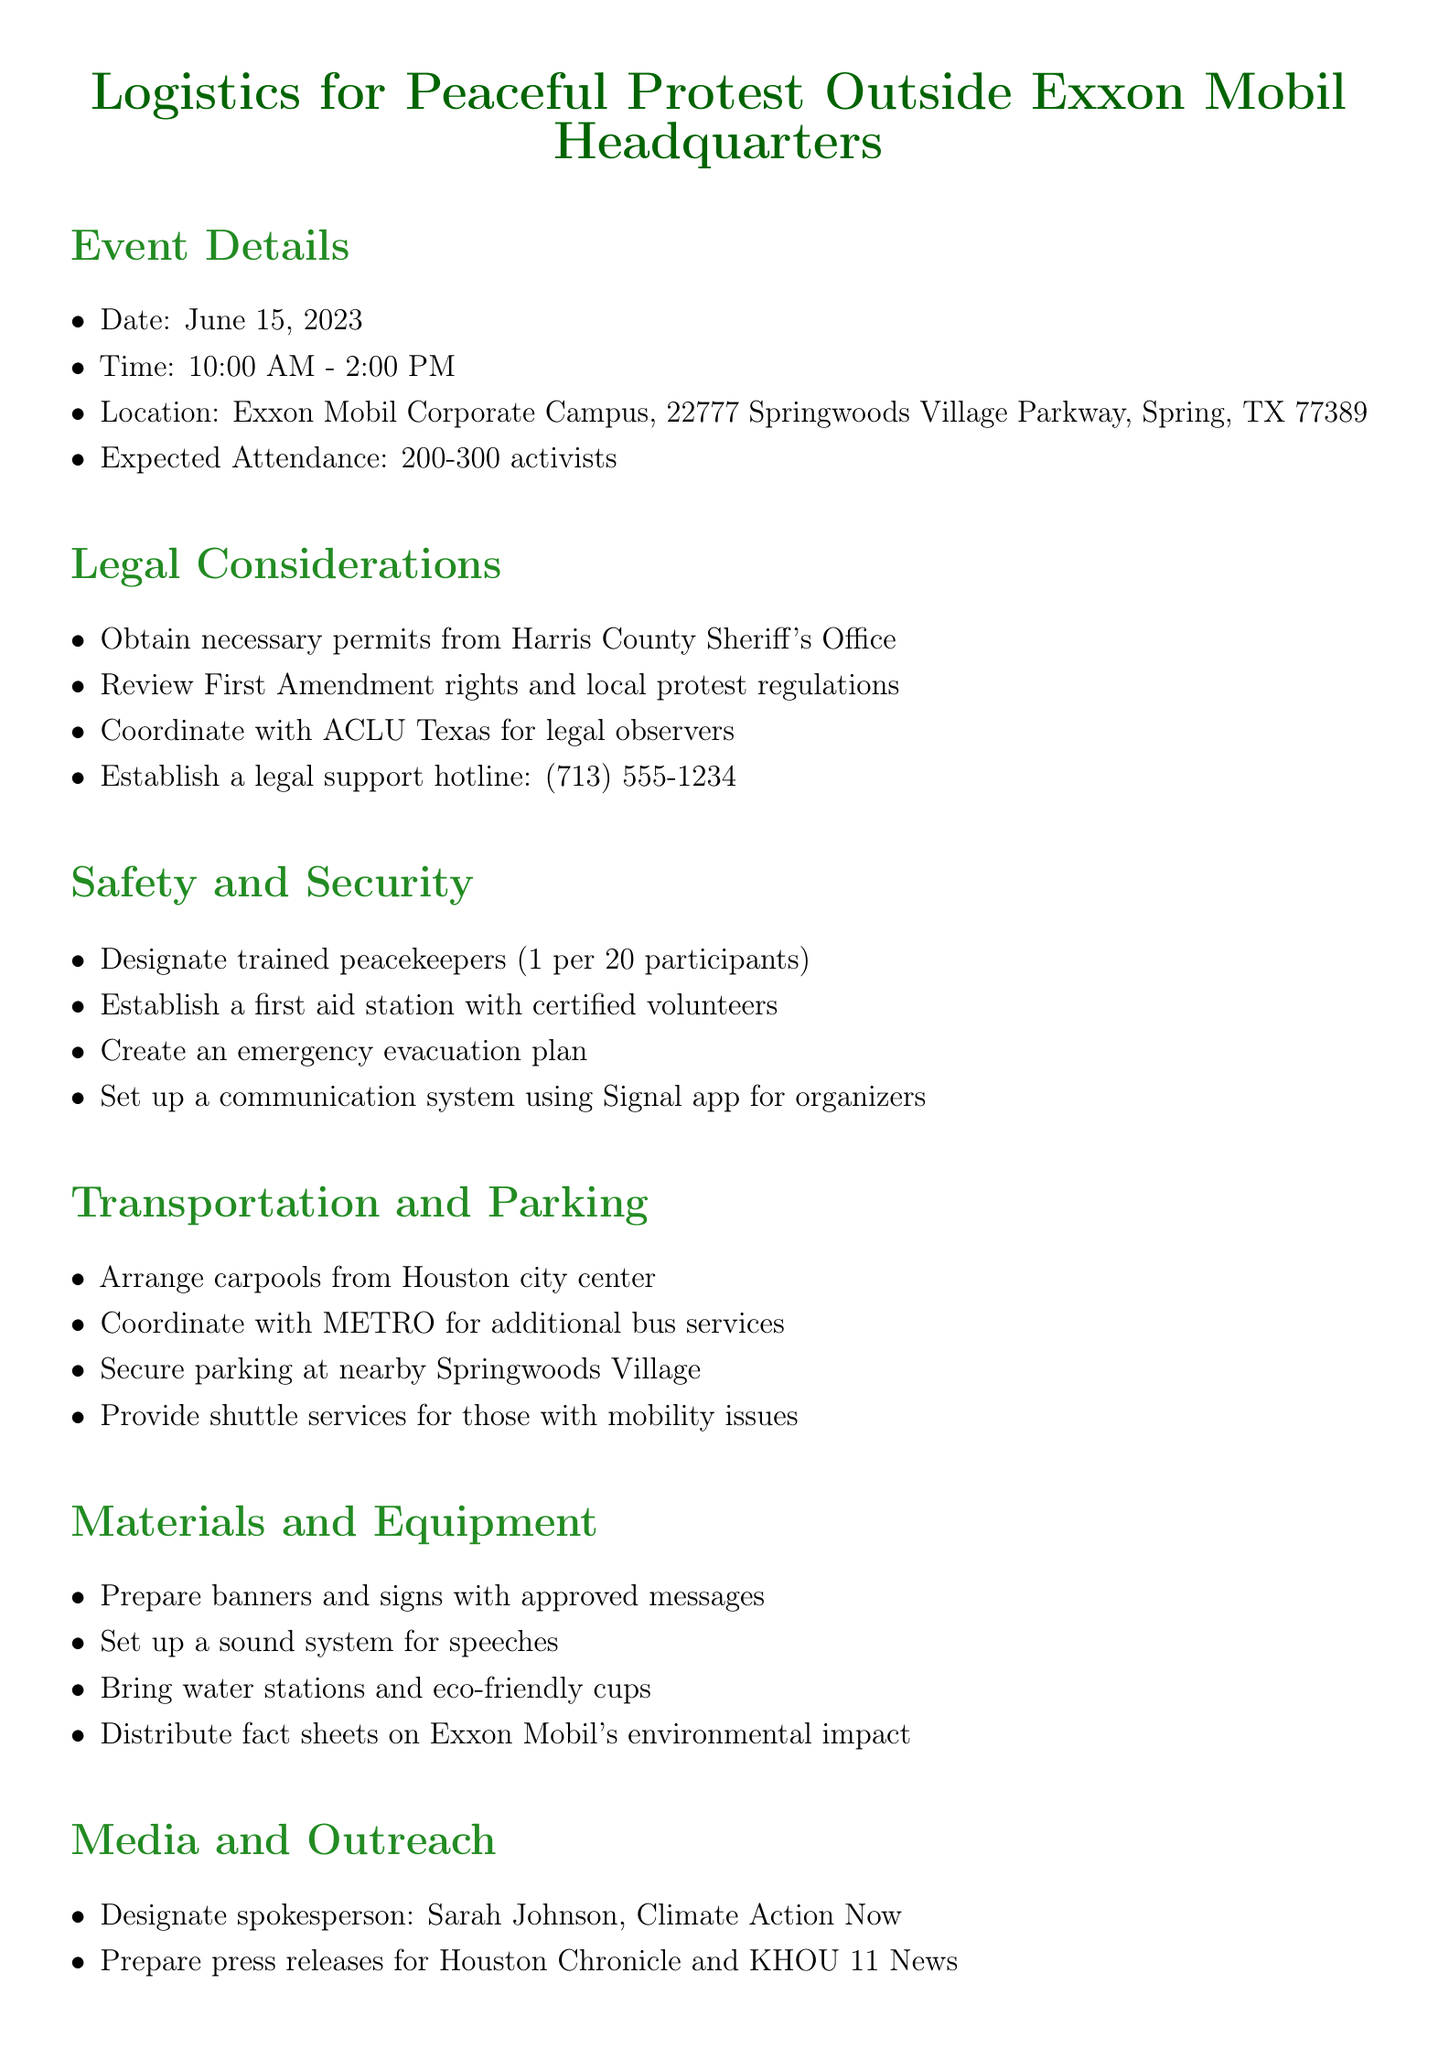what is the date of the protest? The date is mentioned directly in the Event Details section.
Answer: June 15, 2023 what time does the protest start? The starting time is indicated in the Event Details section.
Answer: 10:00 AM how many expected attendees are there? The expected attendance is explicitly stated in the Event Details section.
Answer: 200-300 activists who is the designated spokesperson for media outreach? The spokesperson's name can be found in the Media and Outreach section.
Answer: Sarah Johnson what is the contact number for legal support? The legal support hotline is specified in the Legal Considerations section.
Answer: (713) 555-1234 how many peacekeepers are needed for 100 participants? This requires calculating the ratio based on the guideline provided in the Safety and Security section.
Answer: 5 what should be prepared for the protest? The Materials and Equipment section lists necessary items to be prepared.
Answer: banners and signs where will the protest be held? The location is marked in the Event Details section.
Answer: Exxon Mobil Corporate Campus, 22777 Springwoods Village Parkway, Spring, TX 77389 what is the purpose of the clean-up crews post-event? The purpose of the clean-up crews is described in the Post-Event Planning section.
Answer: to leave no trace 